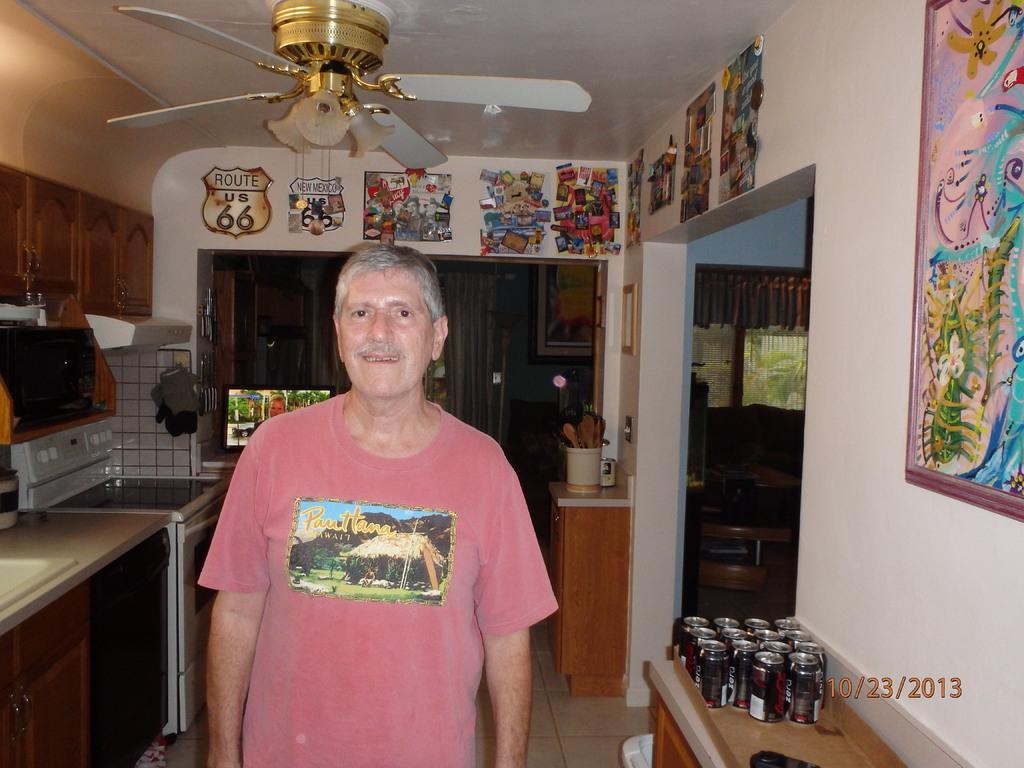How would you summarize this image in a sentence or two? As we can see in the image there is a wall, photo frame, paper, can, a man standing in the front and there is a washing machine, gas and a table. On table there are tins. 